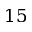Convert formula to latex. <formula><loc_0><loc_0><loc_500><loc_500>1 5</formula> 